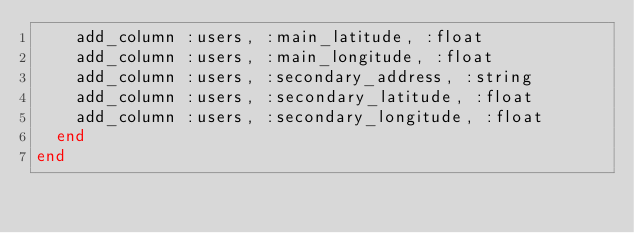Convert code to text. <code><loc_0><loc_0><loc_500><loc_500><_Ruby_>    add_column :users, :main_latitude, :float
    add_column :users, :main_longitude, :float
    add_column :users, :secondary_address, :string
    add_column :users, :secondary_latitude, :float
    add_column :users, :secondary_longitude, :float
  end
end
</code> 